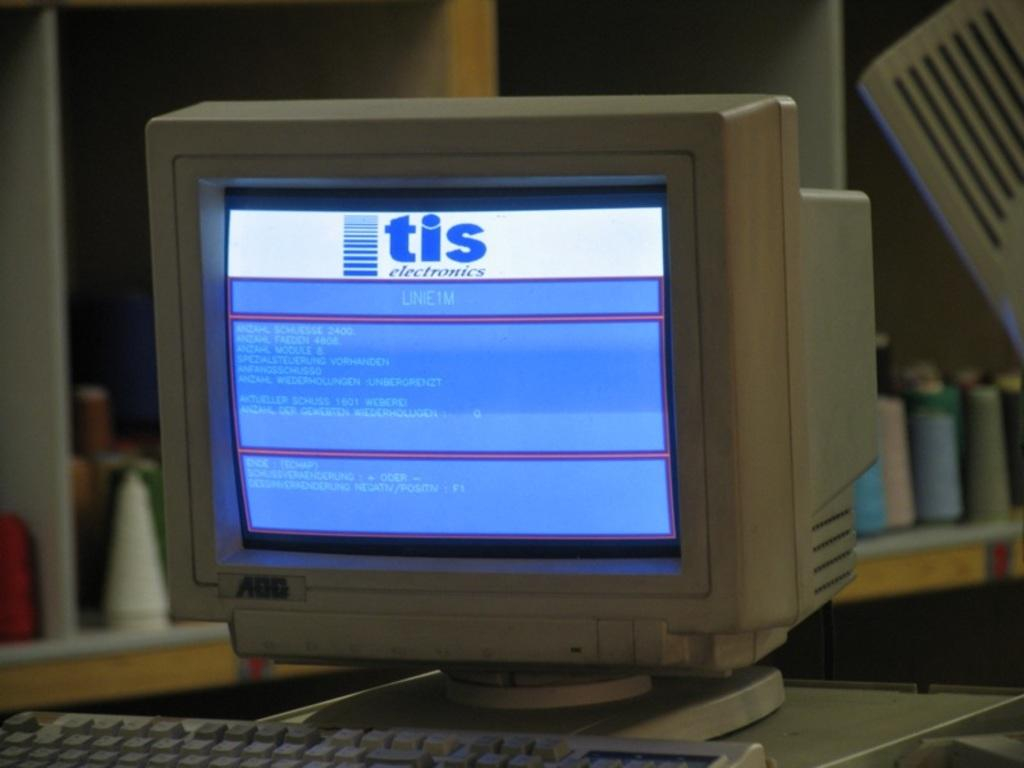<image>
Render a clear and concise summary of the photo. An old AOG computer shows a blue screen with tis electronics written on it 